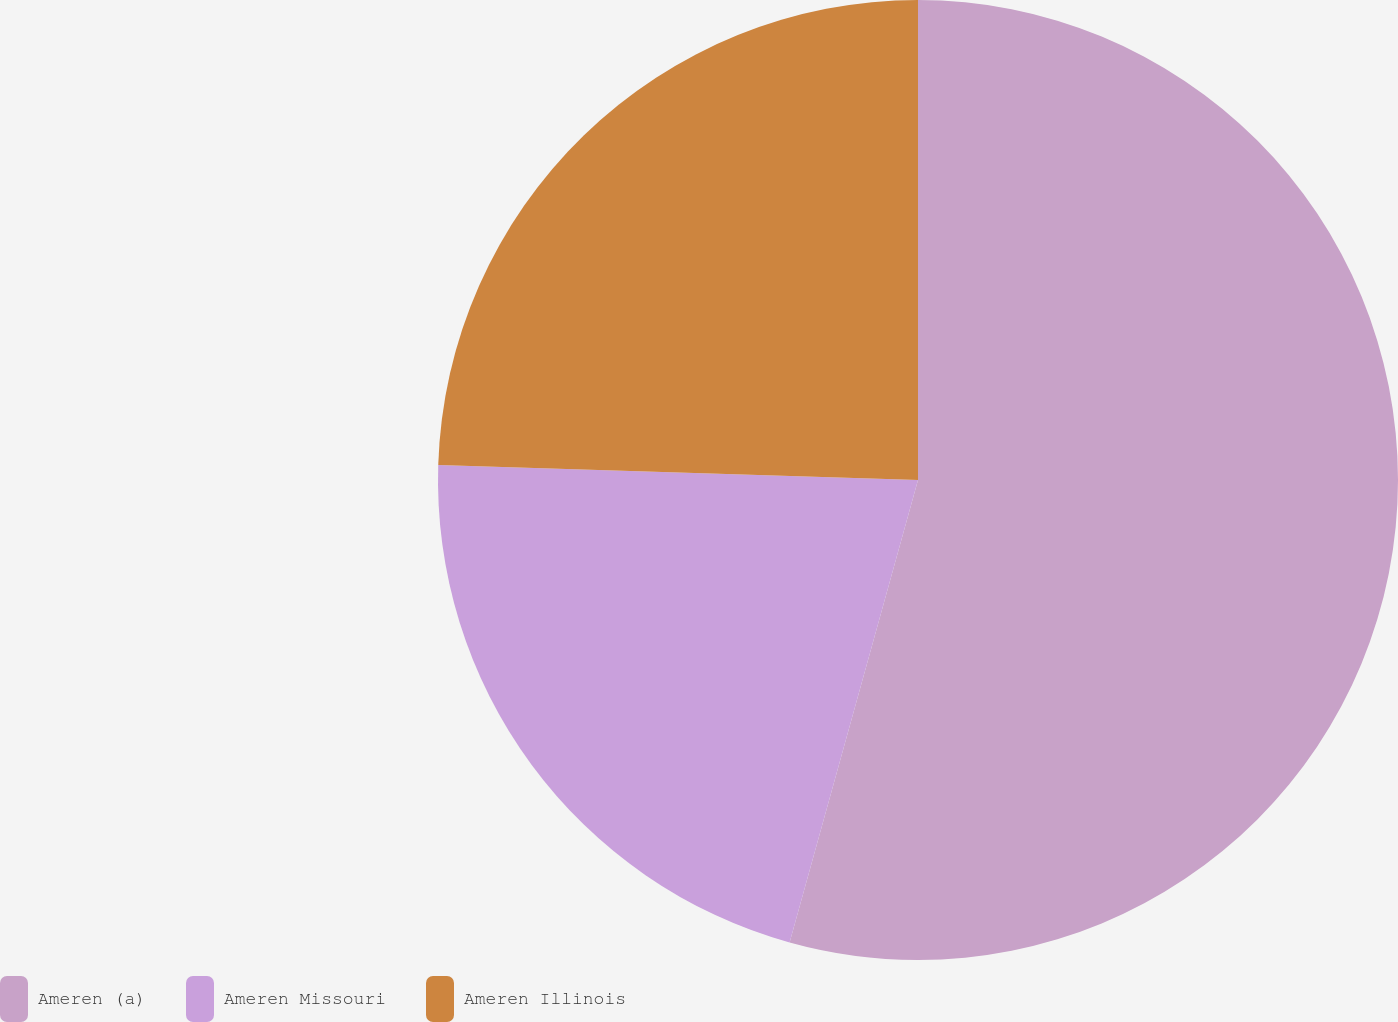Convert chart. <chart><loc_0><loc_0><loc_500><loc_500><pie_chart><fcel>Ameren (a)<fcel>Ameren Missouri<fcel>Ameren Illinois<nl><fcel>54.31%<fcel>21.19%<fcel>24.5%<nl></chart> 